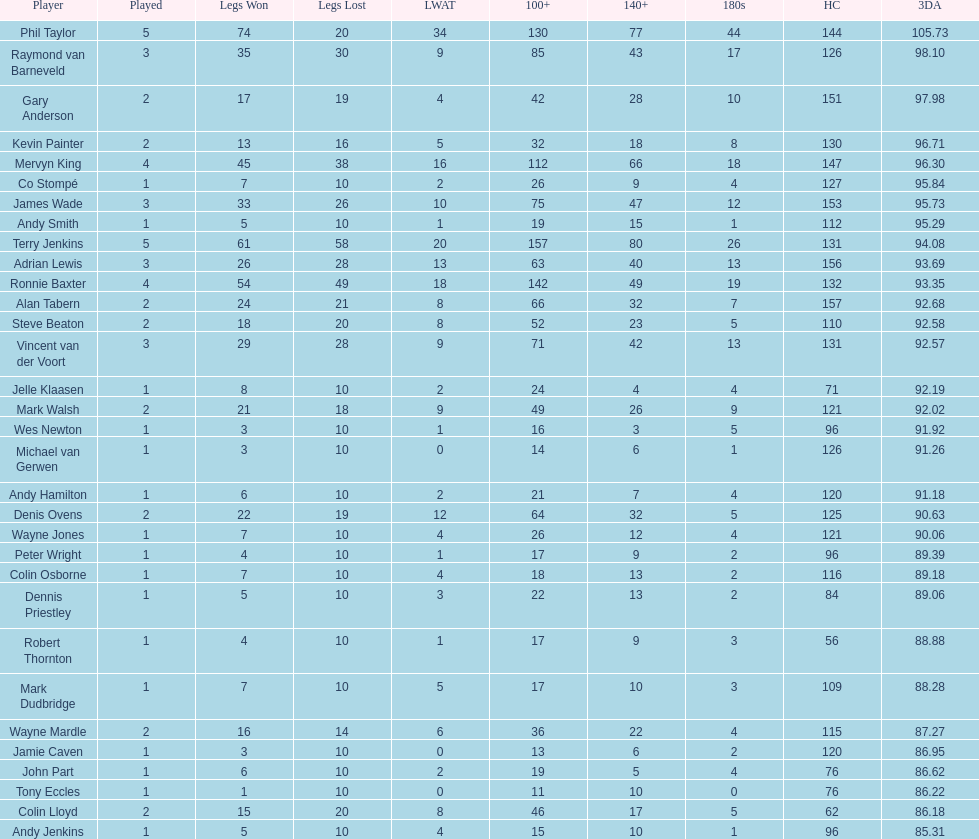What are the number of legs lost by james wade? 26. 